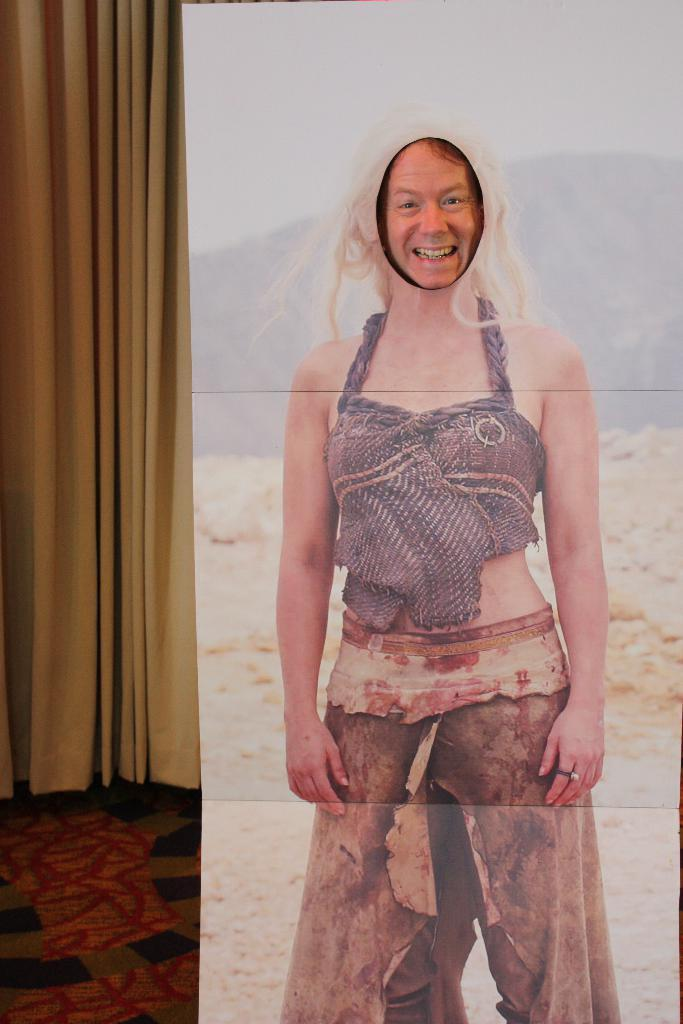What is located on the right side of the image? There is a poster on the right side of the image. What is depicted on the poster? The poster contains a picture of a woman. What can be seen in the middle of the image? There is a person's face visible in the middle of the image. What is present on the left side of the image? There is a curtain on the left side of the image. What type of polish is being applied to the woman's face in the image? There is no indication in the image that any polish is being applied to the woman's face. How does the person in the image react to the news of a death? There is no information about a death or any reaction to it in the image. 